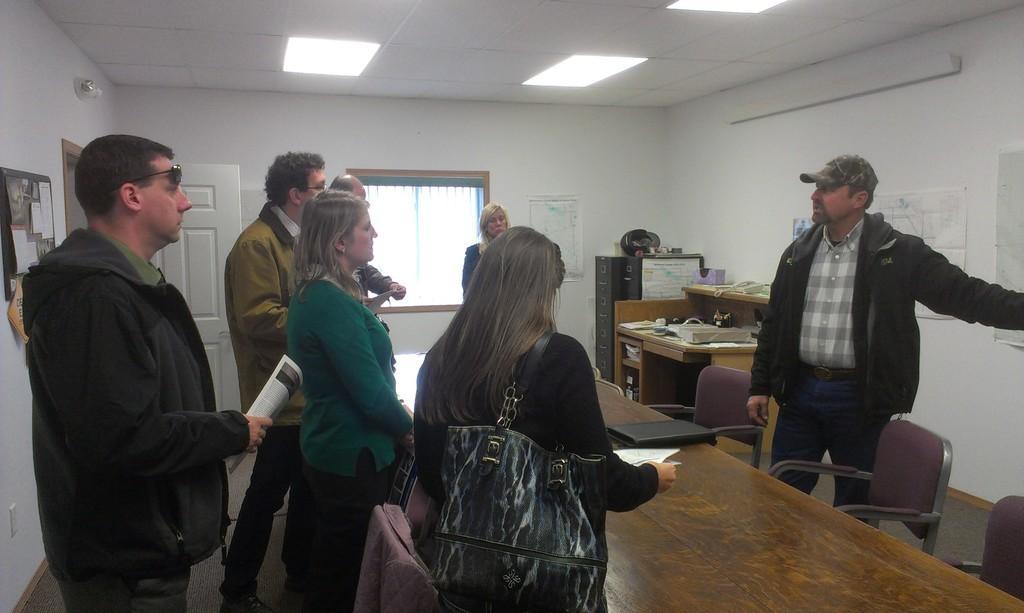In one or two sentences, can you explain what this image depicts? There are a group of people in a room who are around the table and among them there is guy who is standing opposite to them wearing a hat. 